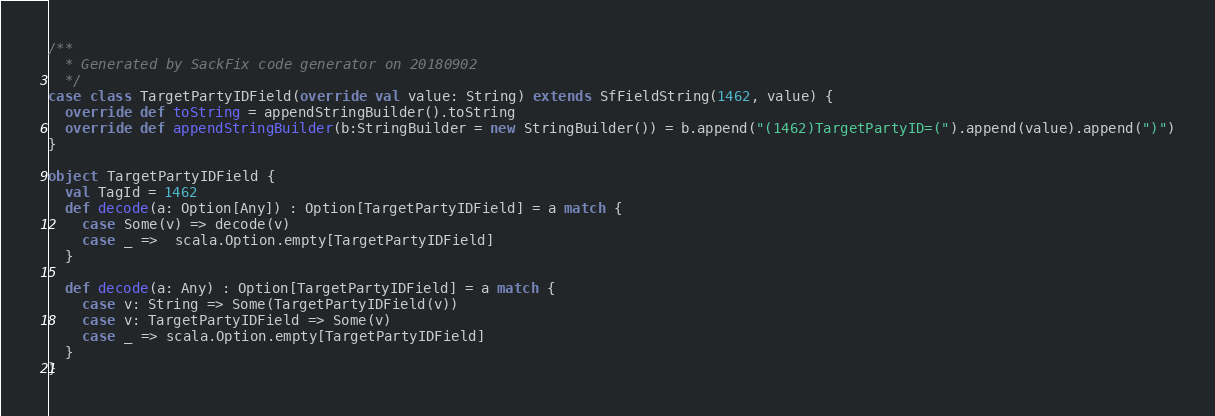Convert code to text. <code><loc_0><loc_0><loc_500><loc_500><_Scala_>/**
  * Generated by SackFix code generator on 20180902
  */
case class TargetPartyIDField(override val value: String) extends SfFieldString(1462, value) {
  override def toString = appendStringBuilder().toString
  override def appendStringBuilder(b:StringBuilder = new StringBuilder()) = b.append("(1462)TargetPartyID=(").append(value).append(")")
}

object TargetPartyIDField {
  val TagId = 1462  
  def decode(a: Option[Any]) : Option[TargetPartyIDField] = a match {
    case Some(v) => decode(v)
    case _ =>  scala.Option.empty[TargetPartyIDField]
  }

  def decode(a: Any) : Option[TargetPartyIDField] = a match {
    case v: String => Some(TargetPartyIDField(v))
    case v: TargetPartyIDField => Some(v)
    case _ => scala.Option.empty[TargetPartyIDField]
  } 
}
</code> 